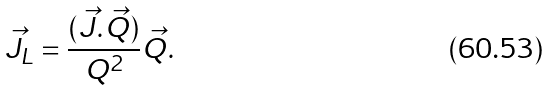<formula> <loc_0><loc_0><loc_500><loc_500>\vec { J } _ { L } = \frac { ( \vec { J } . \vec { Q } ) } { Q ^ { 2 } } \vec { Q } .</formula> 